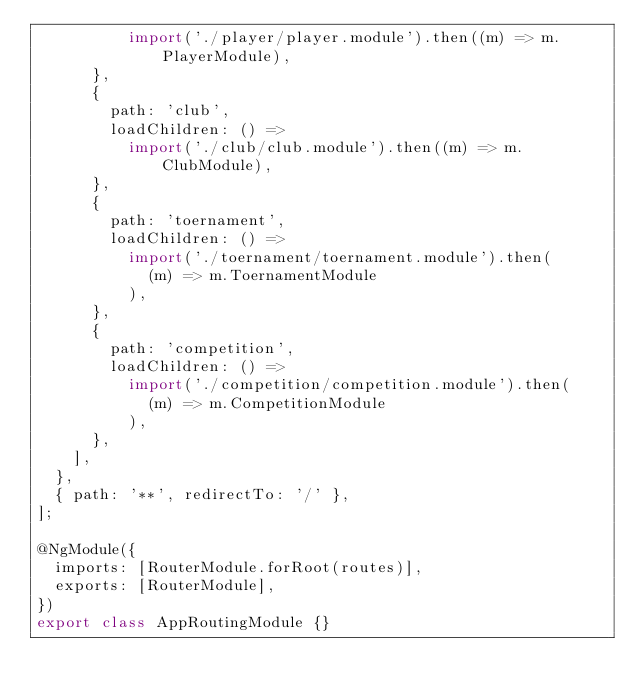Convert code to text. <code><loc_0><loc_0><loc_500><loc_500><_TypeScript_>          import('./player/player.module').then((m) => m.PlayerModule),
      },
      {
        path: 'club',
        loadChildren: () =>
          import('./club/club.module').then((m) => m.ClubModule),
      },
      {
        path: 'toernament',
        loadChildren: () =>
          import('./toernament/toernament.module').then(
            (m) => m.ToernamentModule
          ),
      },
      {
        path: 'competition',
        loadChildren: () =>
          import('./competition/competition.module').then(
            (m) => m.CompetitionModule
          ),
      },
    ],
  },
  { path: '**', redirectTo: '/' },
];

@NgModule({
  imports: [RouterModule.forRoot(routes)],
  exports: [RouterModule],
})
export class AppRoutingModule {}
</code> 